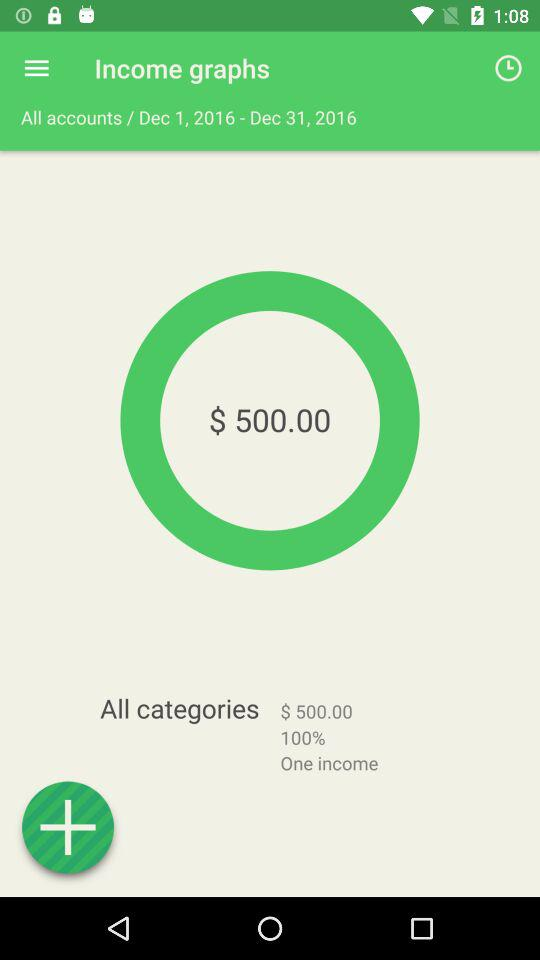For which month is the income calculated? The income is calculated for the month of December. 